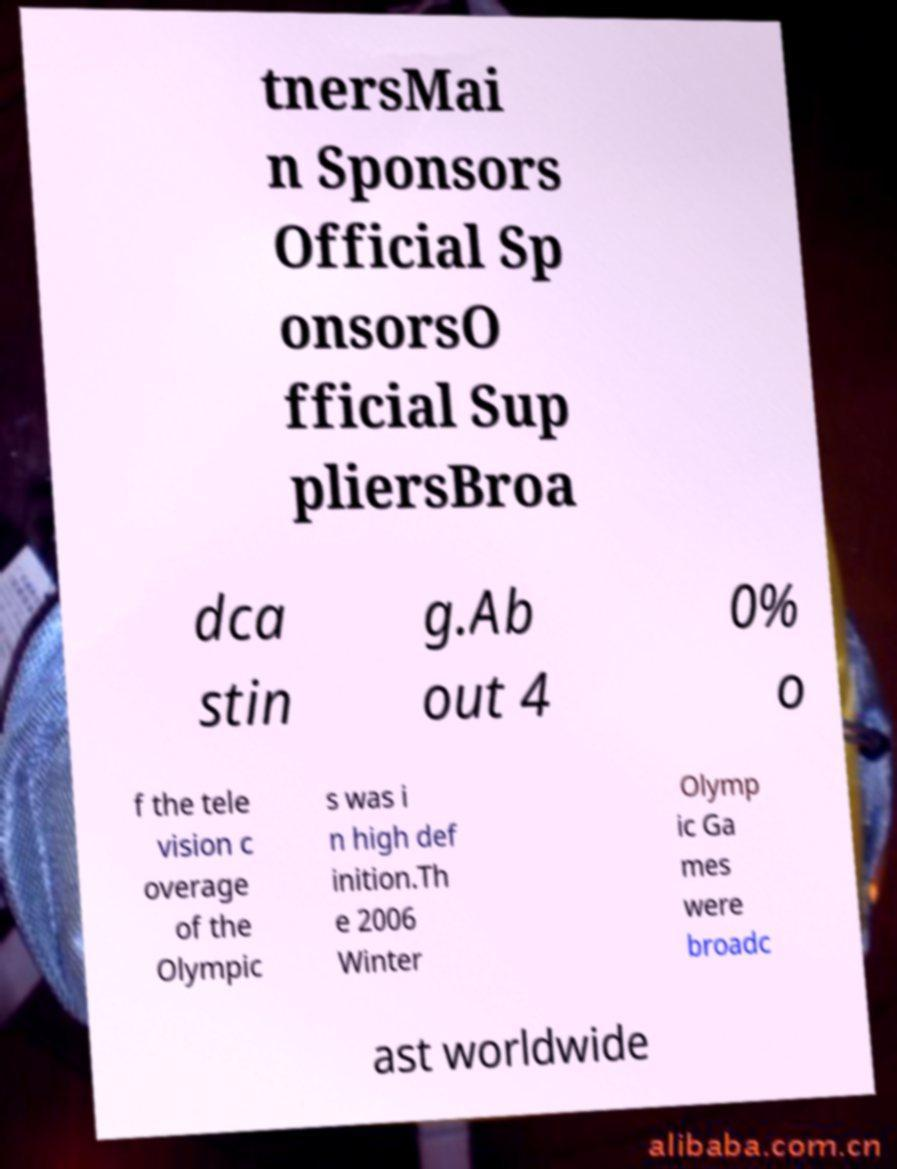Can you read and provide the text displayed in the image?This photo seems to have some interesting text. Can you extract and type it out for me? tnersMai n Sponsors Official Sp onsorsO fficial Sup pliersBroa dca stin g.Ab out 4 0% o f the tele vision c overage of the Olympic s was i n high def inition.Th e 2006 Winter Olymp ic Ga mes were broadc ast worldwide 